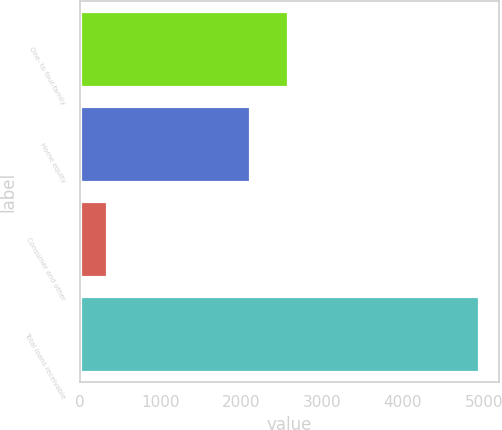Convert chart. <chart><loc_0><loc_0><loc_500><loc_500><bar_chart><fcel>One- to four-family<fcel>Home equity<fcel>Consumer and other<fcel>Total loans receivable<nl><fcel>2574.2<fcel>2114<fcel>341<fcel>4943<nl></chart> 